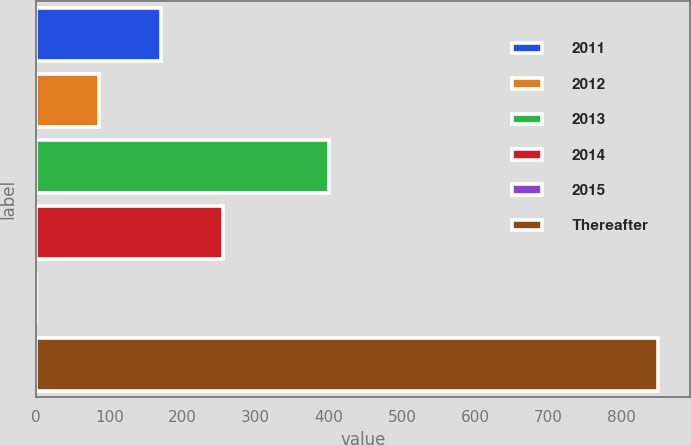Convert chart to OTSL. <chart><loc_0><loc_0><loc_500><loc_500><bar_chart><fcel>2011<fcel>2012<fcel>2013<fcel>2014<fcel>2015<fcel>Thereafter<nl><fcel>170.22<fcel>85.21<fcel>400.5<fcel>255.23<fcel>0.2<fcel>850.3<nl></chart> 